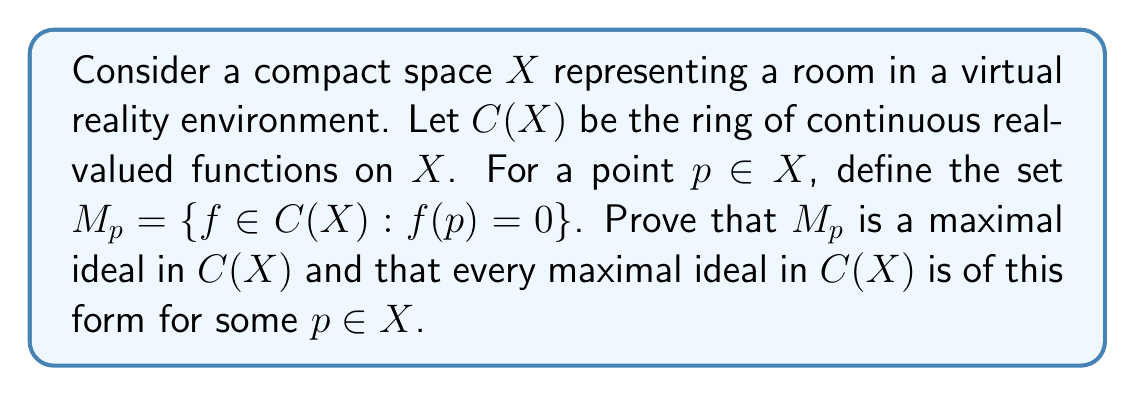Could you help me with this problem? Let's approach this proof in steps:

1) First, we need to show that $M_p$ is an ideal in $C(X)$:
   - For any $f, g \in M_p$, $(f+g)(p) = f(p) + g(p) = 0 + 0 = 0$, so $f+g \in M_p$
   - For any $f \in M_p$ and $h \in C(X)$, $(fh)(p) = f(p)h(p) = 0 \cdot h(p) = 0$, so $fh \in M_p$
   Thus, $M_p$ is an ideal.

2) To prove $M_p$ is maximal, we need to show that the only ideal properly containing $M_p$ is $C(X)$ itself:
   - Suppose $I$ is an ideal such that $M_p \subsetneq I \subseteq C(X)$
   - Then there exists $g \in I$ such that $g(p) \neq 0$
   - Define $f(x) = \frac{1}{g(p)}g(x)$. Then $f \in I$ and $f(p) = 1$
   - For any $h \in C(X)$, we can write $h = (h-h(p)f) + h(p)f$
   - Here, $(h-h(p)f) \in M_p \subset I$ and $h(p)f \in I$
   - Therefore, $h \in I$ for all $h \in C(X)$, so $I = C(X)$

3) Now, we need to show that every maximal ideal is of the form $M_p$ for some $p \in X$:
   - Let $I$ be a maximal ideal in $C(X)$
   - Suppose $I$ is not contained in any $M_p$
   - Then for each $p \in X$, there exists $f_p \in I$ such that $f_p(p) \neq 0$
   - The set $\{f_p^{-1}((0,\infty)) : p \in X\}$ forms an open cover of $X$
   - Since $X$ is compact, there exists a finite subcover $\{f_{p_i}^{-1}((0,\infty)) : i=1,\ldots,n\}$
   - Let $g = \sum_{i=1}^n f_{p_i}^2$. Then $g \in I$ and $g(x) > 0$ for all $x \in X$
   - Define $h(x) = \frac{1}{g(x)}$. Then $gh = 1 \in I$
   - This implies $I = C(X)$, contradicting the maximality of $I$
   - Therefore, $I$ must be contained in some $M_p$
   - Since $I$ is maximal, $I = M_p$

Thus, we have shown that $M_p$ is maximal and every maximal ideal is of this form.
Answer: Every maximal ideal in $C(X)$ is of the form $M_p = \{f \in C(X) : f(p) = 0\}$ for some $p \in X$, where $X$ is a compact space. 